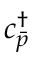Convert formula to latex. <formula><loc_0><loc_0><loc_500><loc_500>{ c } _ { \bar { p } } ^ { \dagger }</formula> 